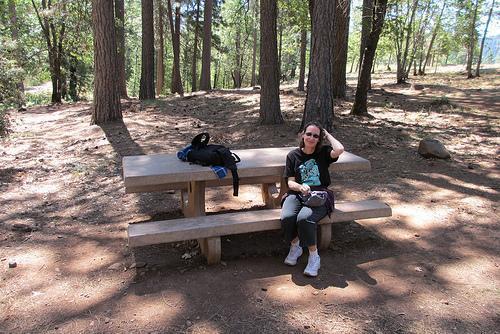How many people are shown?
Give a very brief answer. 1. How many hands are touching head?
Give a very brief answer. 1. 